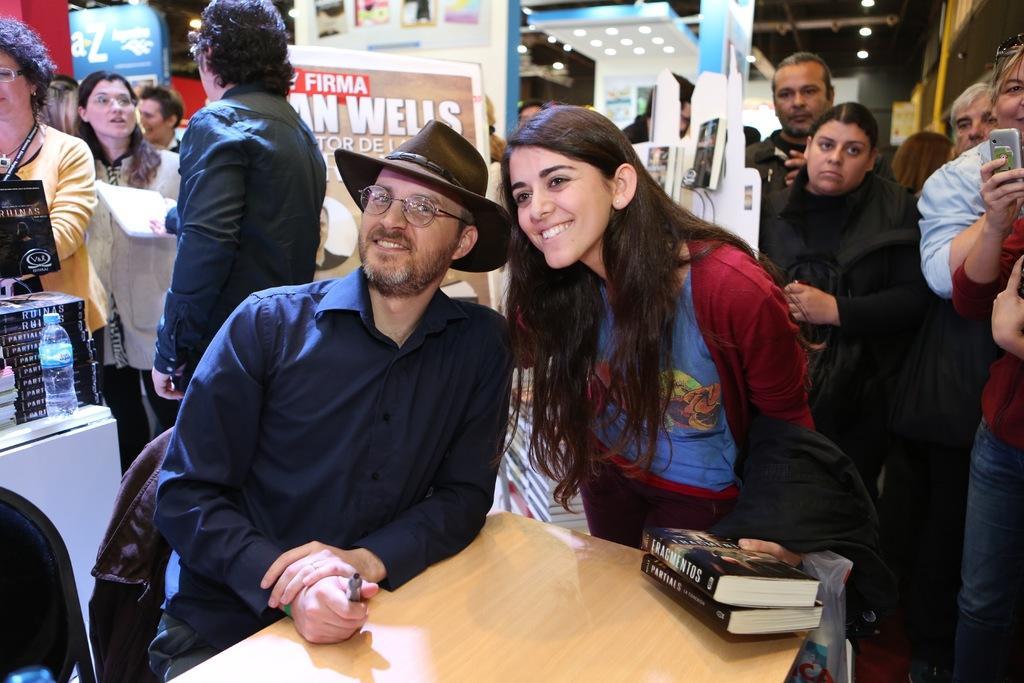Describe this image in one or two sentences. This picture is clicked inside. In the foreground there is a wooden table and we can see a man wearing blue color shirt, hat and sitting on a chair and there is a woman smiling, holding some books and standing on the ground. In the background we can see the group of people standing. On the left there are some books and some other items are placed on the top of the table and we can see the banners on which the text is printed. At the top we can see the ceiling lights, roof and many other items. 